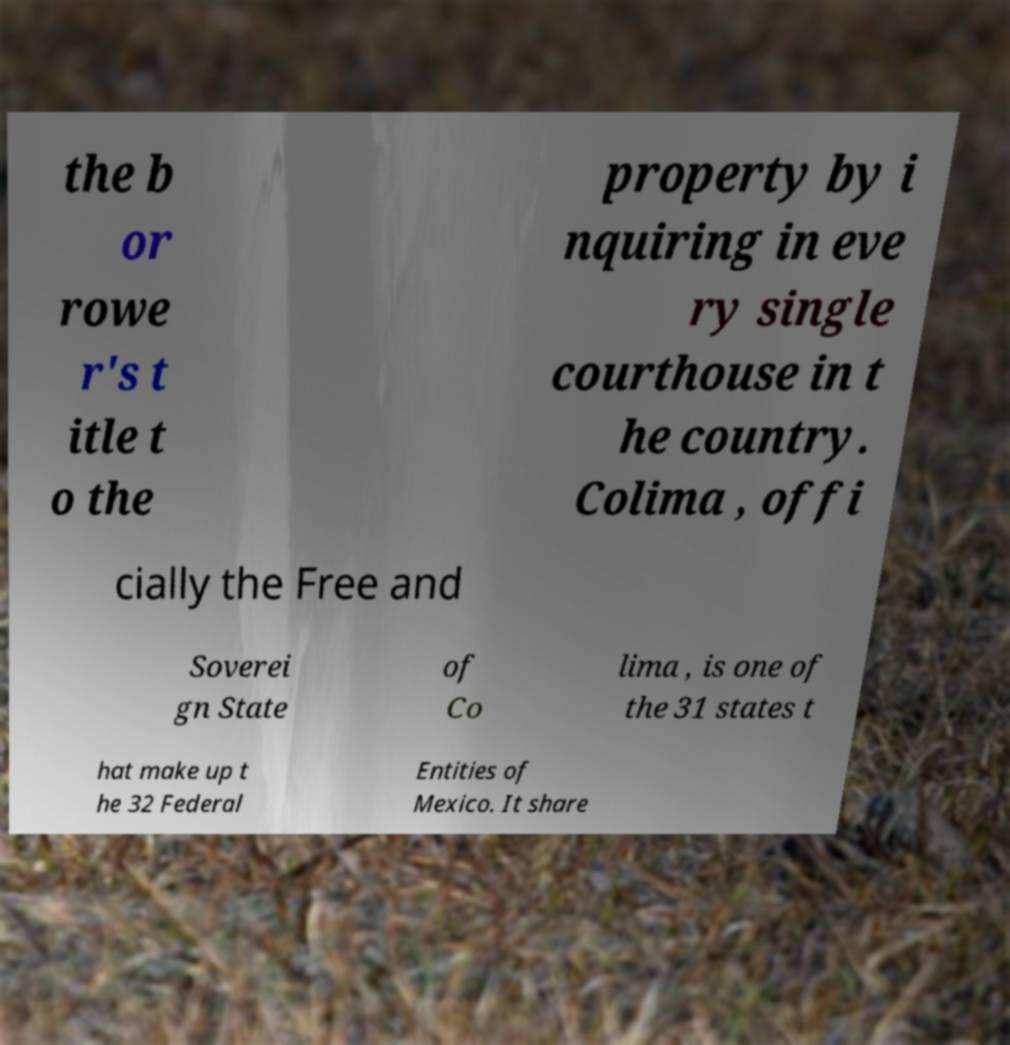What messages or text are displayed in this image? I need them in a readable, typed format. the b or rowe r's t itle t o the property by i nquiring in eve ry single courthouse in t he country. Colima , offi cially the Free and Soverei gn State of Co lima , is one of the 31 states t hat make up t he 32 Federal Entities of Mexico. It share 